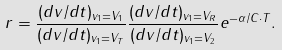<formula> <loc_0><loc_0><loc_500><loc_500>r = \frac { ( d v / d t ) _ { v _ { 1 } = V _ { 1 } } } { ( d v / d t ) _ { v _ { 1 } = V _ { T } } } \frac { ( d v / d t ) _ { v _ { 1 } = V _ { R } } } { ( d v / d t ) _ { v _ { 1 } = V _ { 2 } } } e ^ { - \alpha / C \cdot T } .</formula> 